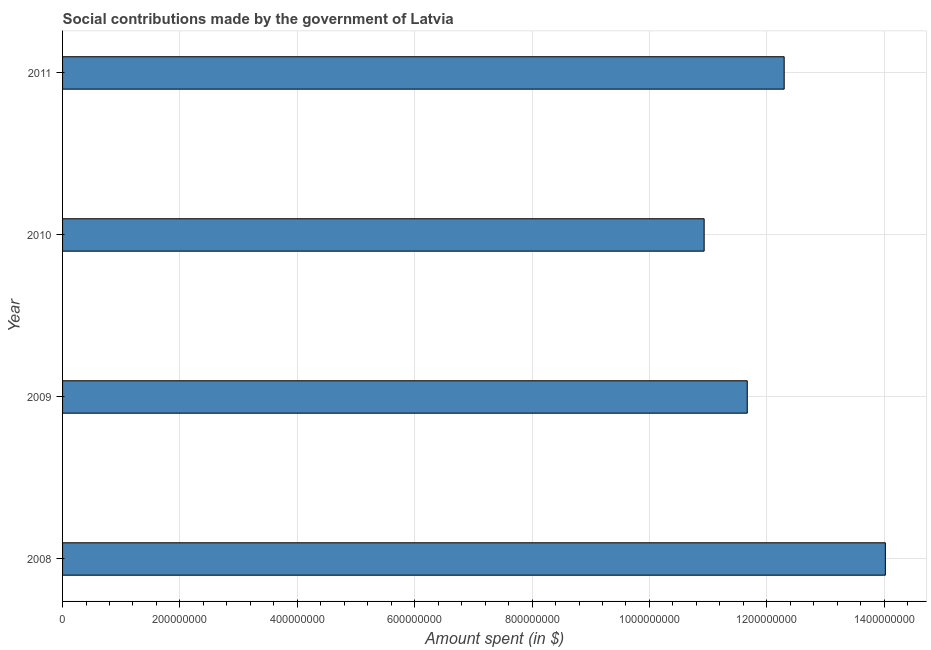Does the graph contain any zero values?
Keep it short and to the point. No. Does the graph contain grids?
Ensure brevity in your answer.  Yes. What is the title of the graph?
Offer a very short reply. Social contributions made by the government of Latvia. What is the label or title of the X-axis?
Ensure brevity in your answer.  Amount spent (in $). What is the label or title of the Y-axis?
Ensure brevity in your answer.  Year. What is the amount spent in making social contributions in 2010?
Make the answer very short. 1.09e+09. Across all years, what is the maximum amount spent in making social contributions?
Your answer should be very brief. 1.40e+09. Across all years, what is the minimum amount spent in making social contributions?
Make the answer very short. 1.09e+09. In which year was the amount spent in making social contributions maximum?
Your answer should be very brief. 2008. In which year was the amount spent in making social contributions minimum?
Ensure brevity in your answer.  2010. What is the sum of the amount spent in making social contributions?
Your response must be concise. 4.89e+09. What is the difference between the amount spent in making social contributions in 2009 and 2011?
Offer a terse response. -6.29e+07. What is the average amount spent in making social contributions per year?
Provide a succinct answer. 1.22e+09. What is the median amount spent in making social contributions?
Offer a terse response. 1.20e+09. What is the ratio of the amount spent in making social contributions in 2009 to that in 2010?
Your response must be concise. 1.07. What is the difference between the highest and the second highest amount spent in making social contributions?
Provide a short and direct response. 1.72e+08. What is the difference between the highest and the lowest amount spent in making social contributions?
Ensure brevity in your answer.  3.09e+08. How many bars are there?
Offer a very short reply. 4. Are all the bars in the graph horizontal?
Your response must be concise. Yes. How many years are there in the graph?
Provide a short and direct response. 4. What is the difference between two consecutive major ticks on the X-axis?
Provide a short and direct response. 2.00e+08. Are the values on the major ticks of X-axis written in scientific E-notation?
Your response must be concise. No. What is the Amount spent (in $) in 2008?
Your response must be concise. 1.40e+09. What is the Amount spent (in $) in 2009?
Keep it short and to the point. 1.17e+09. What is the Amount spent (in $) of 2010?
Offer a very short reply. 1.09e+09. What is the Amount spent (in $) in 2011?
Keep it short and to the point. 1.23e+09. What is the difference between the Amount spent (in $) in 2008 and 2009?
Offer a very short reply. 2.35e+08. What is the difference between the Amount spent (in $) in 2008 and 2010?
Your response must be concise. 3.09e+08. What is the difference between the Amount spent (in $) in 2008 and 2011?
Make the answer very short. 1.72e+08. What is the difference between the Amount spent (in $) in 2009 and 2010?
Ensure brevity in your answer.  7.35e+07. What is the difference between the Amount spent (in $) in 2009 and 2011?
Offer a very short reply. -6.29e+07. What is the difference between the Amount spent (in $) in 2010 and 2011?
Your answer should be very brief. -1.36e+08. What is the ratio of the Amount spent (in $) in 2008 to that in 2009?
Provide a succinct answer. 1.2. What is the ratio of the Amount spent (in $) in 2008 to that in 2010?
Give a very brief answer. 1.28. What is the ratio of the Amount spent (in $) in 2008 to that in 2011?
Provide a succinct answer. 1.14. What is the ratio of the Amount spent (in $) in 2009 to that in 2010?
Your answer should be compact. 1.07. What is the ratio of the Amount spent (in $) in 2009 to that in 2011?
Your answer should be very brief. 0.95. What is the ratio of the Amount spent (in $) in 2010 to that in 2011?
Your answer should be very brief. 0.89. 